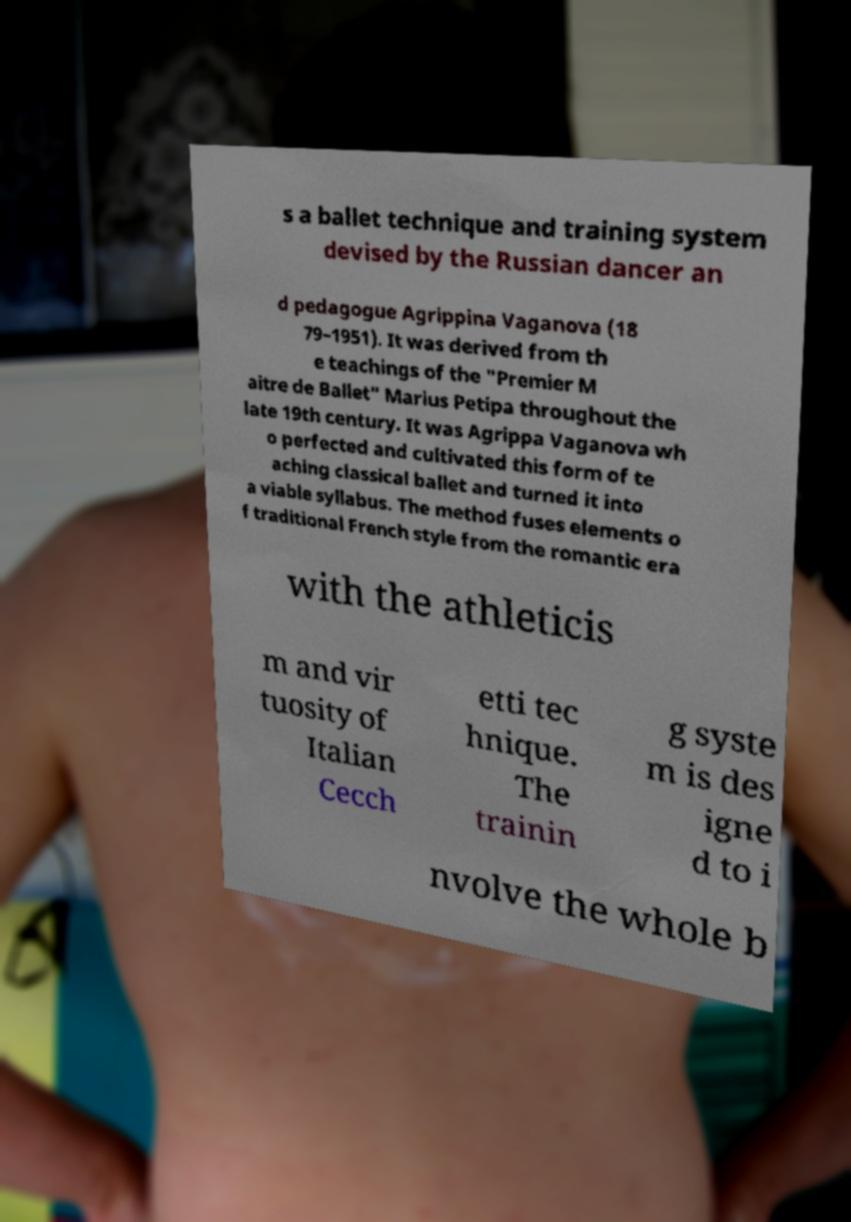Please read and relay the text visible in this image. What does it say? s a ballet technique and training system devised by the Russian dancer an d pedagogue Agrippina Vaganova (18 79–1951). It was derived from th e teachings of the "Premier M aitre de Ballet" Marius Petipa throughout the late 19th century. It was Agrippa Vaganova wh o perfected and cultivated this form of te aching classical ballet and turned it into a viable syllabus. The method fuses elements o f traditional French style from the romantic era with the athleticis m and vir tuosity of Italian Cecch etti tec hnique. The trainin g syste m is des igne d to i nvolve the whole b 